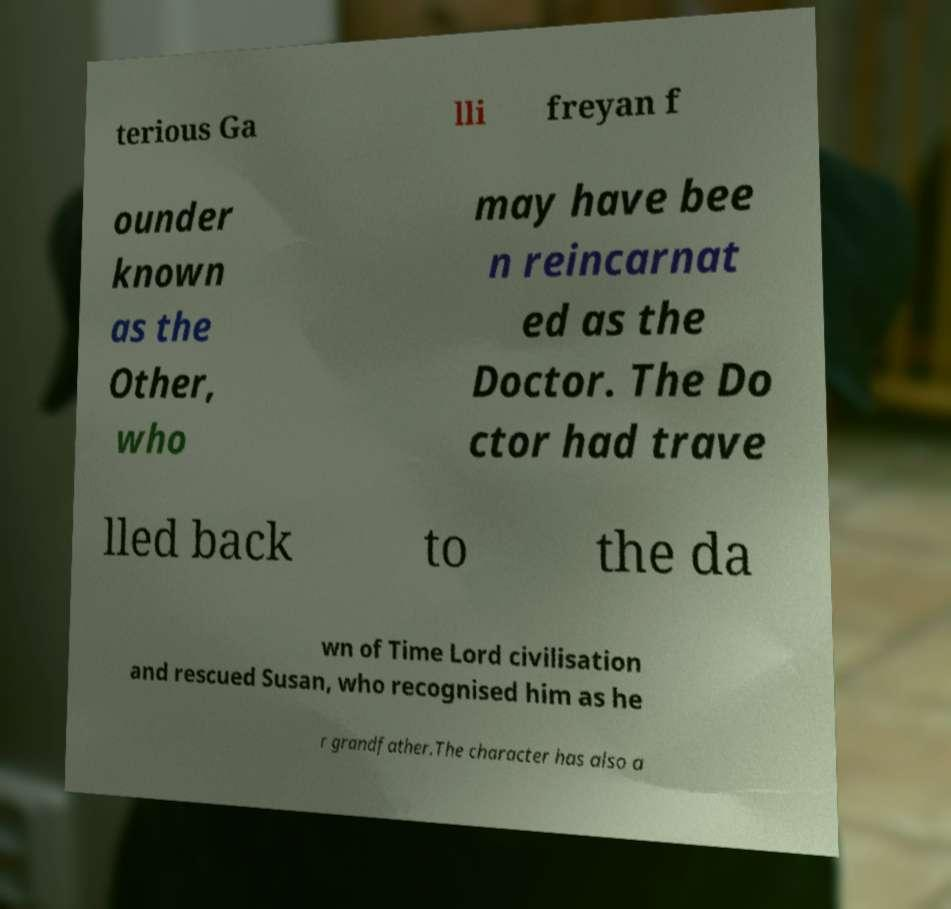Could you assist in decoding the text presented in this image and type it out clearly? terious Ga lli freyan f ounder known as the Other, who may have bee n reincarnat ed as the Doctor. The Do ctor had trave lled back to the da wn of Time Lord civilisation and rescued Susan, who recognised him as he r grandfather.The character has also a 